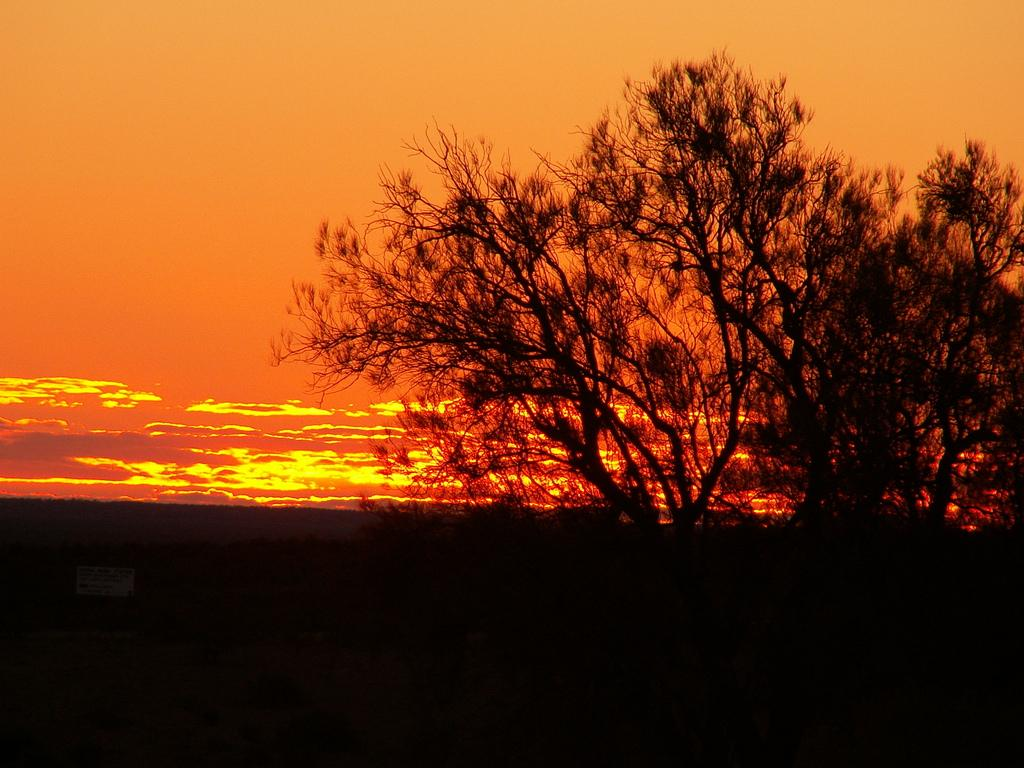What type of vegetation can be seen in the image? There are trees in the image. How would you describe the color of the sky in the background? The sky in the background has a yellowish orange color. What else can be seen in the sky besides the color? Clouds are visible in the sky. Can you see a lipstick on the tree in the image? There is no lipstick present in the image. Is there a home visible among the trees in the image? There is no home visible in the image; only trees are present. 